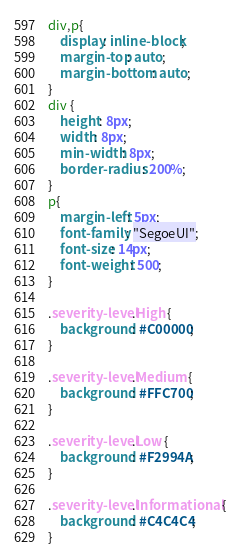<code> <loc_0><loc_0><loc_500><loc_500><_CSS_>div,p{
    display: inline-block;
    margin-top: auto;
    margin-bottom: auto;
}
div {
    height: 8px;
    width: 8px;
    min-width: 8px;
    border-radius: 200%;
}
p{
    margin-left: 5px;
    font-family: "SegoeUI";
    font-size: 14px;  
    font-weight: 500;
}

.severity-level.High {
    background: #C00000;
}

.severity-level.Medium {
    background: #FFC700;
}

.severity-level.Low {
    background: #F2994A;
}

.severity-level.Informational {
    background: #C4C4C4;
}</code> 